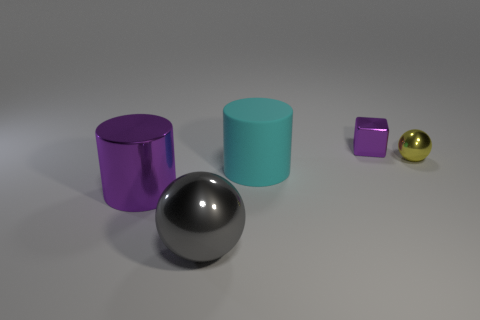Add 1 big spheres. How many objects exist? 6 Subtract all cubes. How many objects are left? 4 Subtract 1 spheres. How many spheres are left? 1 Subtract all yellow cylinders. Subtract all cyan balls. How many cylinders are left? 2 Subtract all purple spheres. How many cyan cylinders are left? 1 Subtract all tiny green rubber cylinders. Subtract all purple metallic blocks. How many objects are left? 4 Add 2 large cyan matte things. How many large cyan matte things are left? 3 Add 1 tiny purple metal objects. How many tiny purple metal objects exist? 2 Subtract 1 gray spheres. How many objects are left? 4 